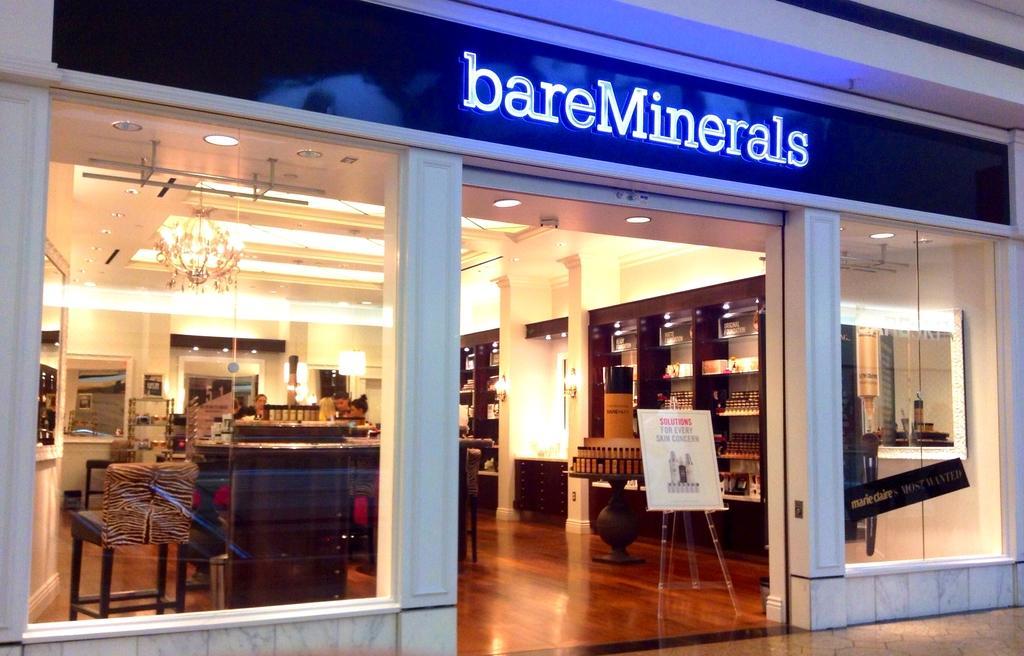Can you describe this image briefly? In this image we can see a store and there is a board with some text at the top of the image. We can see few people in the store and there are some chairs and other objects and we can see some lights attached to the ceiling. 